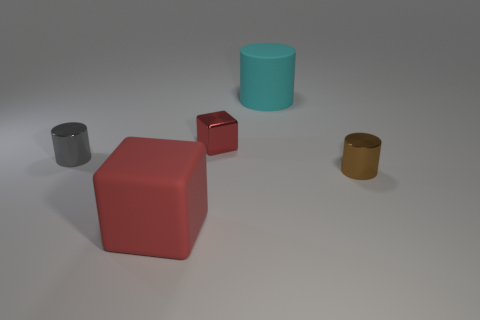Are there any other things of the same color as the large matte block?
Give a very brief answer. Yes. There is a big thing that is the same color as the small block; what is its shape?
Offer a very short reply. Cube. How many objects are on the right side of the tiny metallic block and behind the tiny gray object?
Offer a very short reply. 1. Is there anything else that has the same shape as the big cyan thing?
Your answer should be very brief. Yes. How many other things are there of the same size as the gray metal cylinder?
Your answer should be very brief. 2. Do the cyan matte object that is to the right of the large red matte thing and the red object behind the small gray metallic cylinder have the same size?
Your answer should be very brief. No. How many objects are either red objects or tiny metal cylinders right of the matte cylinder?
Offer a very short reply. 3. What is the size of the red thing behind the red rubber block?
Provide a succinct answer. Small. Are there fewer cyan matte objects that are right of the tiny cube than tiny brown things that are behind the large cyan matte thing?
Keep it short and to the point. No. There is a object that is left of the shiny block and behind the large red matte object; what is its material?
Your answer should be very brief. Metal. 